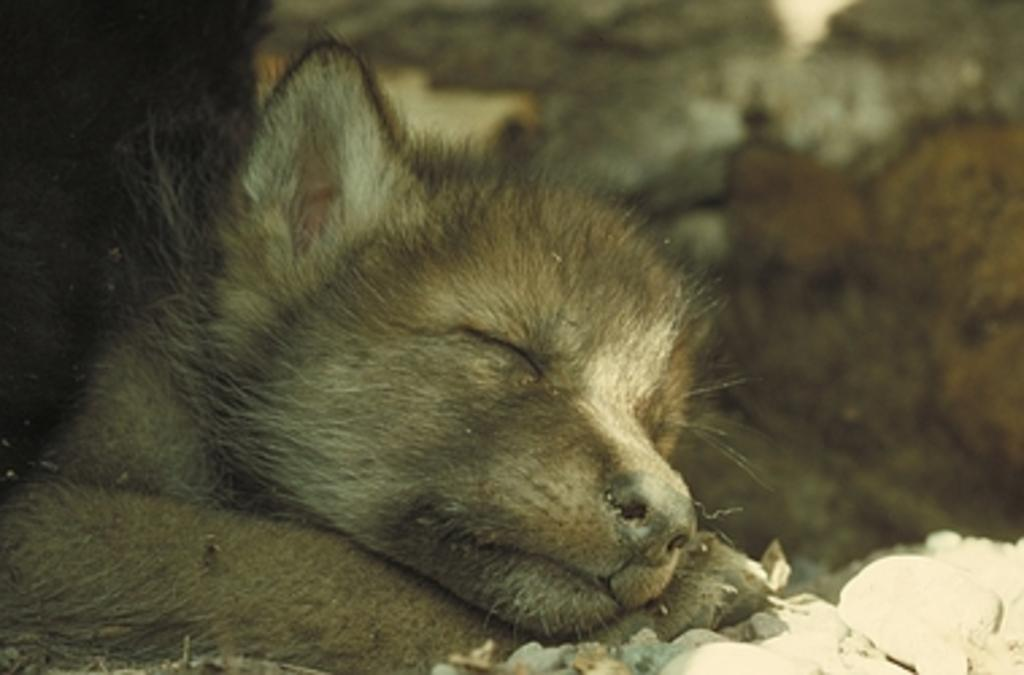What type of animal is present in the image? There is an animal in the image, but its specific type cannot be determined from the provided facts. What other objects can be seen in the image? There are stones visible in the image. Can you describe the background of the image? The background of the image is slightly blurred. What type of berry is being used as a whistle in the image? There is no berry or whistle present in the image. 